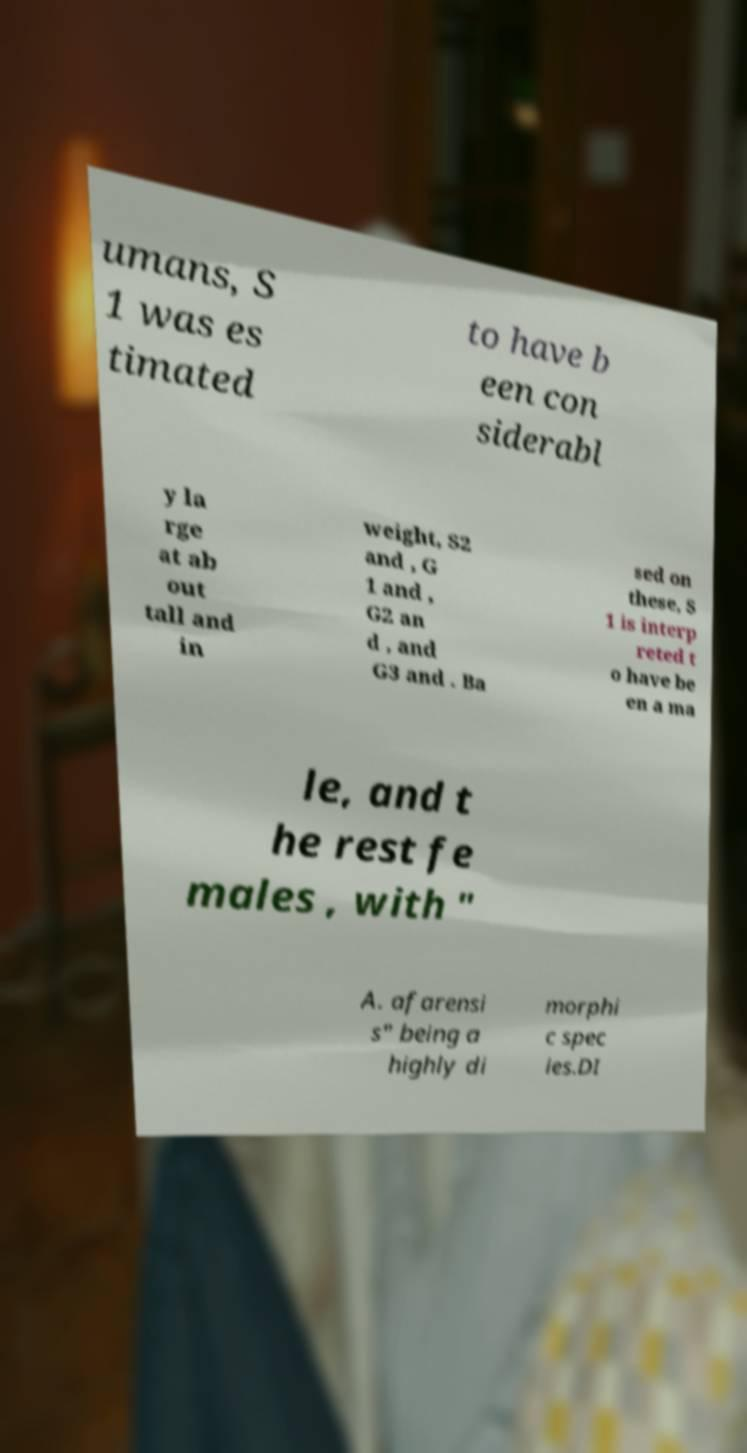Please identify and transcribe the text found in this image. umans, S 1 was es timated to have b een con siderabl y la rge at ab out tall and in weight, S2 and , G 1 and , G2 an d , and G3 and . Ba sed on these, S 1 is interp reted t o have be en a ma le, and t he rest fe males , with " A. afarensi s" being a highly di morphi c spec ies.DI 